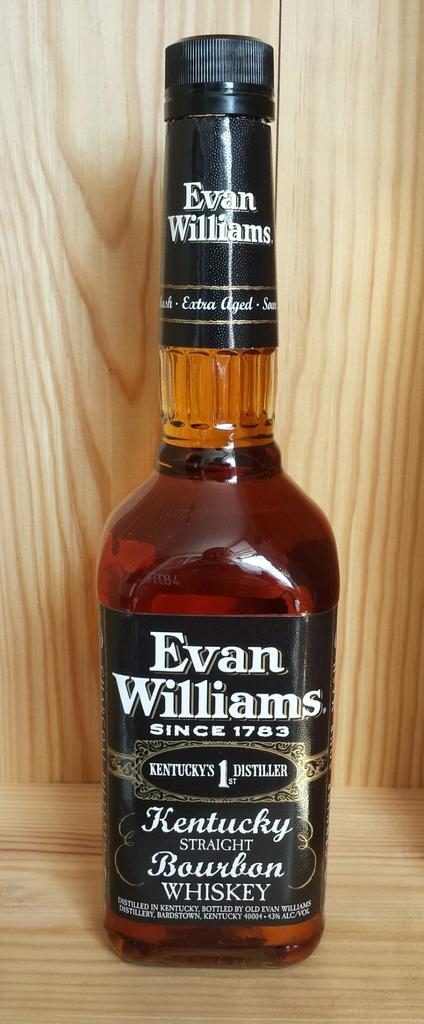In what year was evan williams established?
Provide a short and direct response. 1783. What state is this made in?
Provide a succinct answer. Kentucky. 